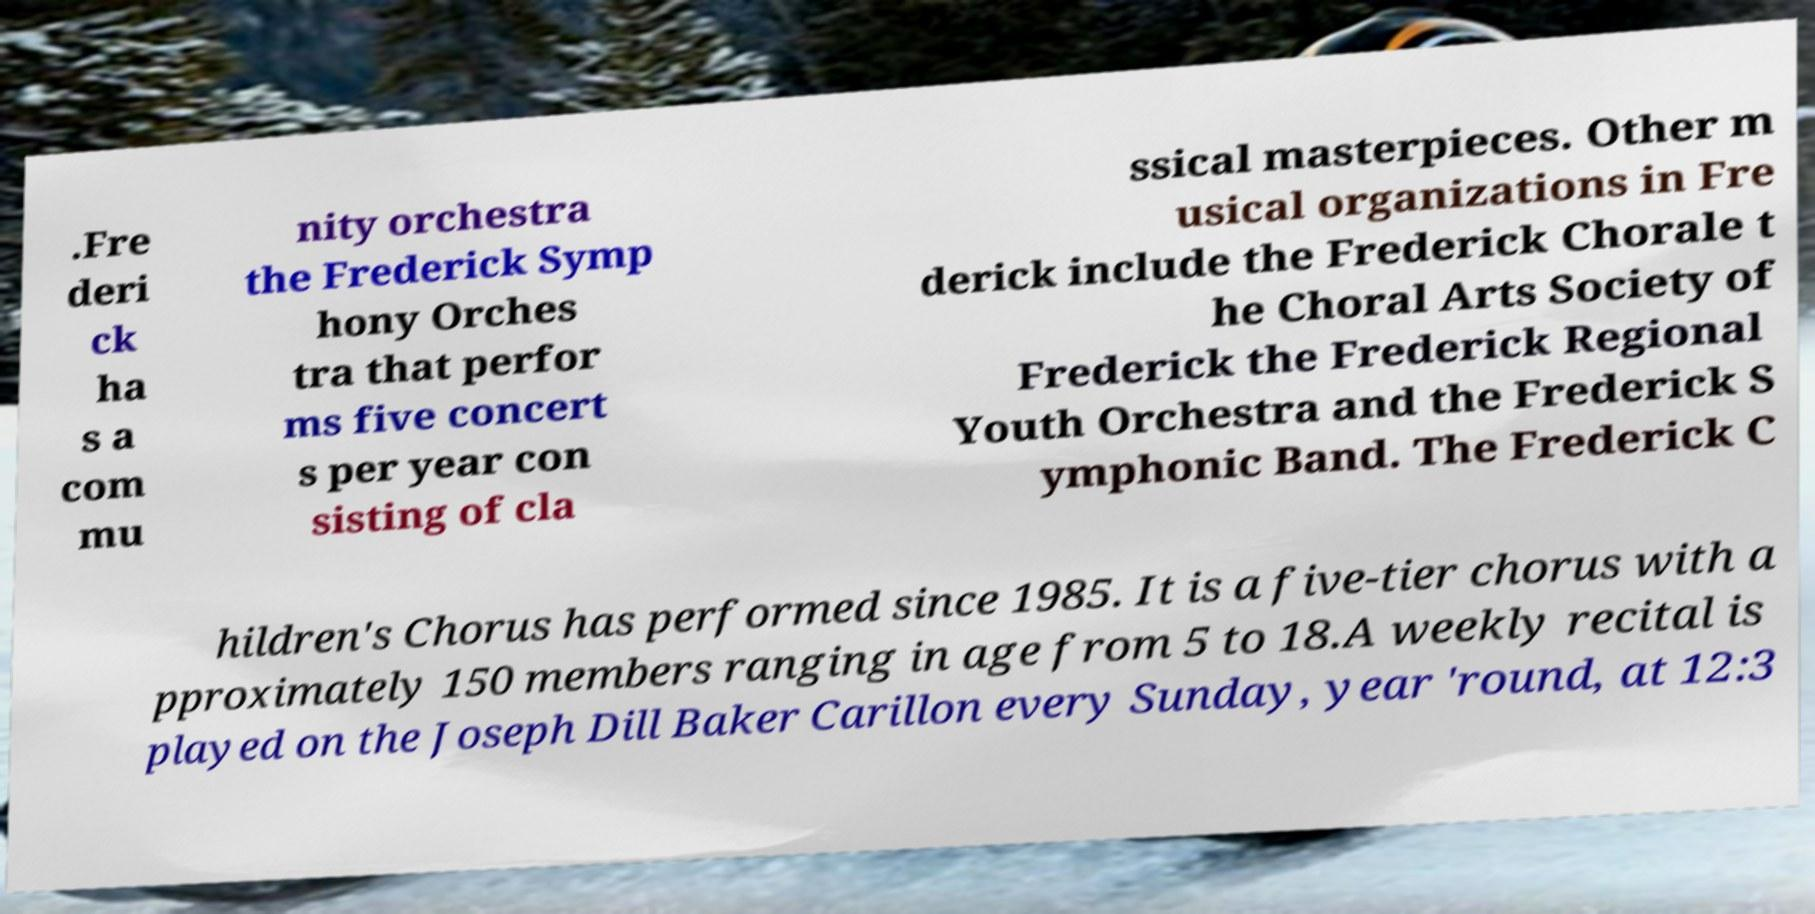For documentation purposes, I need the text within this image transcribed. Could you provide that? .Fre deri ck ha s a com mu nity orchestra the Frederick Symp hony Orches tra that perfor ms five concert s per year con sisting of cla ssical masterpieces. Other m usical organizations in Fre derick include the Frederick Chorale t he Choral Arts Society of Frederick the Frederick Regional Youth Orchestra and the Frederick S ymphonic Band. The Frederick C hildren's Chorus has performed since 1985. It is a five-tier chorus with a pproximately 150 members ranging in age from 5 to 18.A weekly recital is played on the Joseph Dill Baker Carillon every Sunday, year 'round, at 12:3 